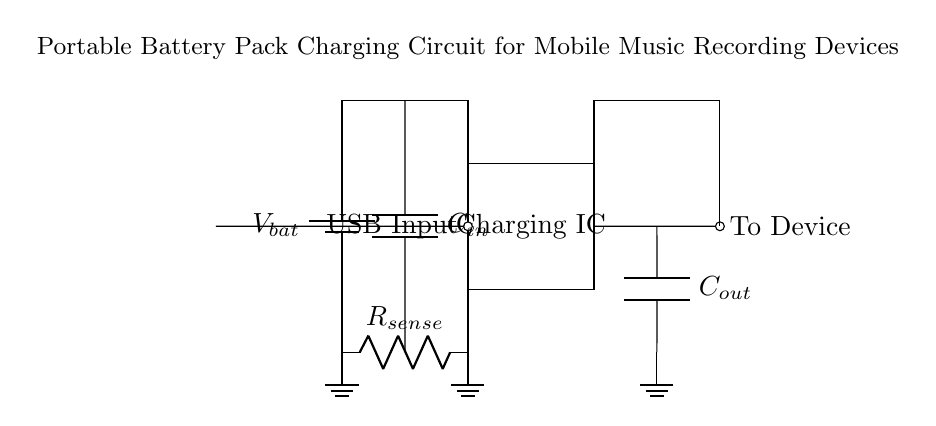What is the input source for charging? The input source is indicated as a USB input, which supplies power to the charging circuit.
Answer: USB input Which component is used to sense current? The current sense resistor, labeled as R sense, is shown in the circuit, which helps in measuring the flow of current.
Answer: R sense What type of circuit is this? The circuit is a charging circuit specifically designed for portable battery packs used in mobile devices, particularly for music recording.
Answer: Charging circuit How many capacitors are present in the circuit? The circuit has two capacitors: C in and C out used for stabilizing input and output voltages.
Answer: Two What is the role of the charging IC? The charging IC manages the charging process for the battery by regulating voltage and current from the USB input to charge the battery effectively.
Answer: Regulates charging What is the output of this circuit? The output of the circuit is directed to the mobile device that requires power for operation during music recording.
Answer: To device What connects the battery pack to the charging IC? The connection is established with a direct line from the battery pack to the charging IC, facilitating power flow for charging.
Answer: Direct line 